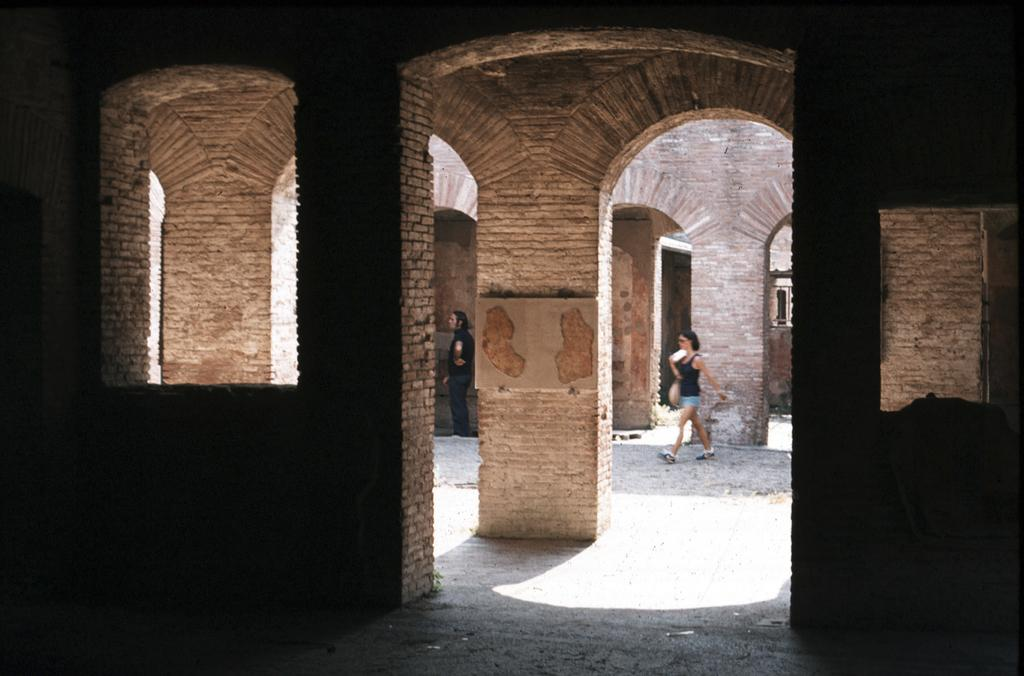What architectural features are present in the foreground of the image? There are arches and pillars in the foreground of the image. Can you describe the people in the background of the image? Unfortunately, the facts provided do not give any information about the people in the background. What is the primary focus of the image? The primary focus of the image is the arches and pillars in the foreground. How many tents are visible in the image? There are no tents present in the image. What is the size of the arches in the image? The facts provided do not give any information about the size of the arches. 